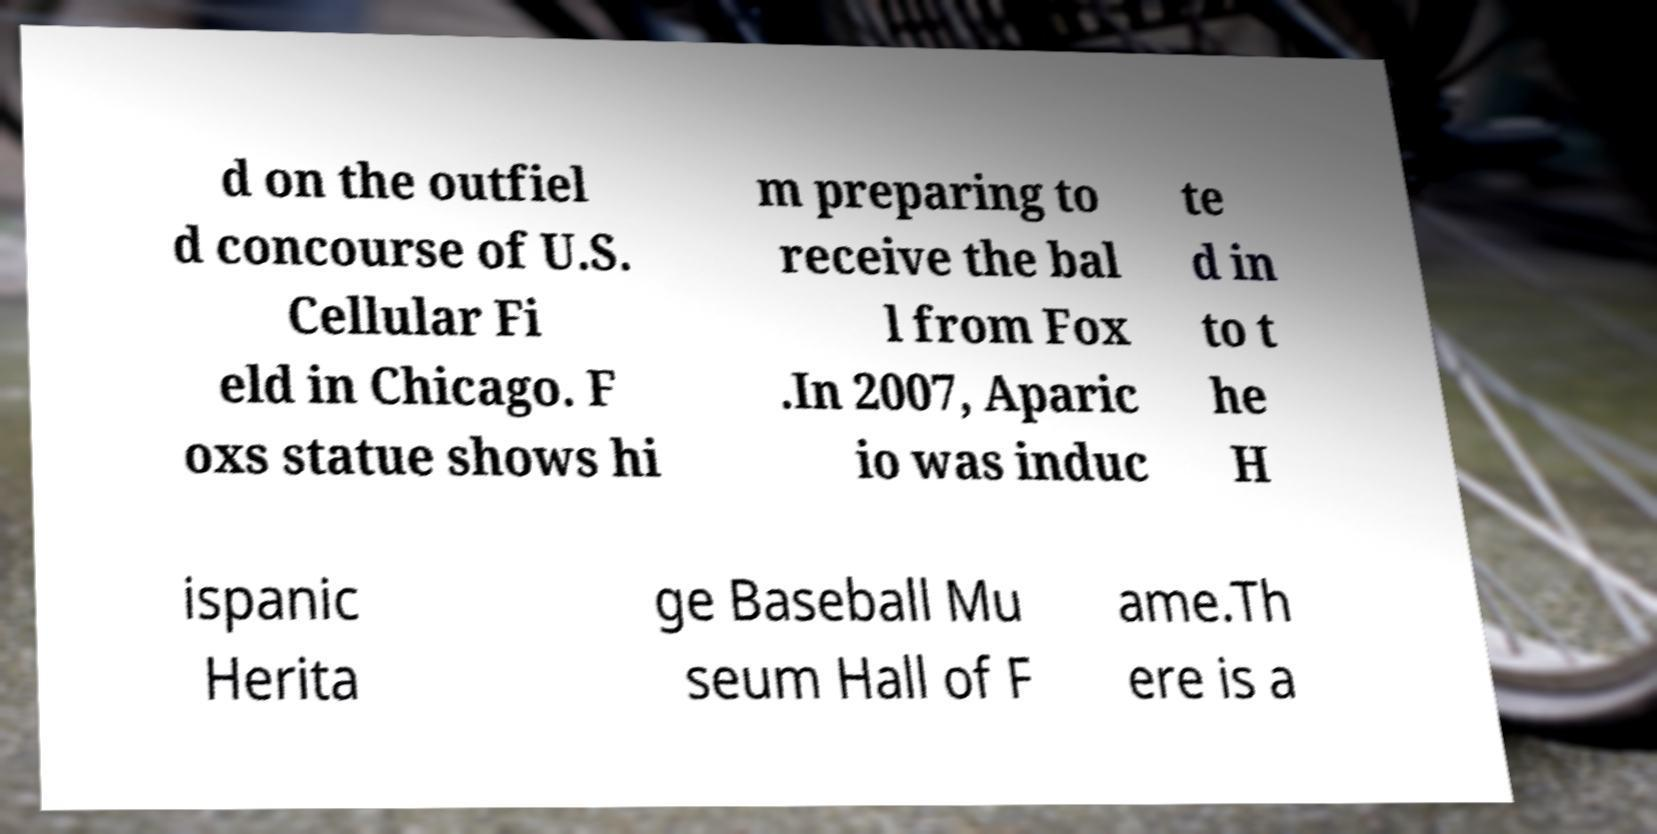What messages or text are displayed in this image? I need them in a readable, typed format. d on the outfiel d concourse of U.S. Cellular Fi eld in Chicago. F oxs statue shows hi m preparing to receive the bal l from Fox .In 2007, Aparic io was induc te d in to t he H ispanic Herita ge Baseball Mu seum Hall of F ame.Th ere is a 